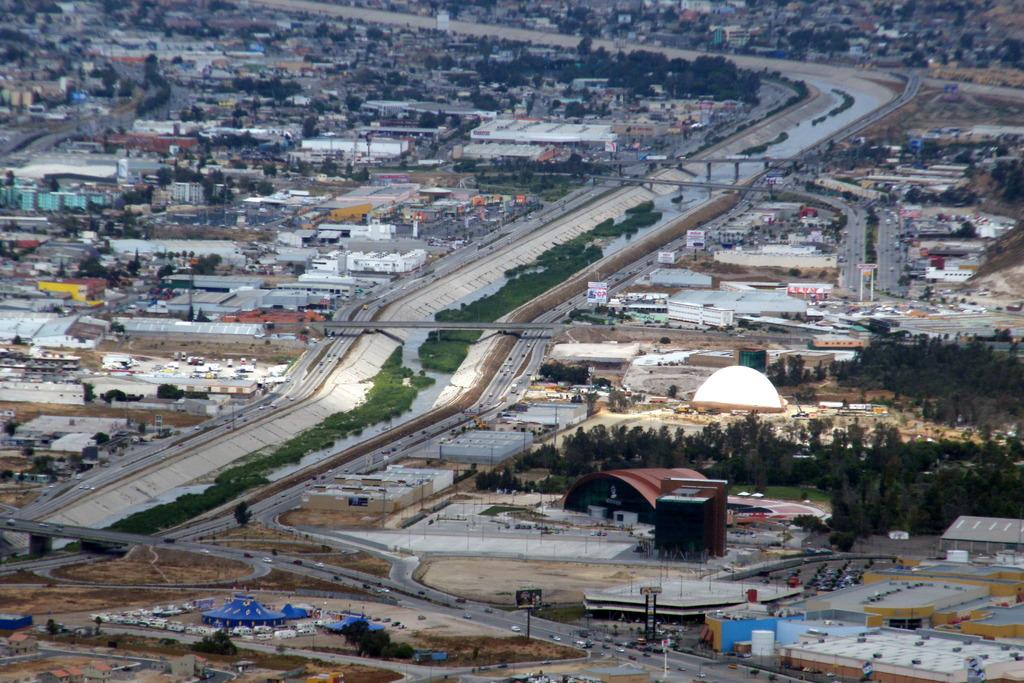What is the perspective of the image? The image shows a top view of a city. What structures can be seen in the image? There are buildings, trees, a canal, bridges, roads, and vehicles visible in the image. What type of transportation is present in the image? Vehicles can be seen in the image. What are the signs or advertisements in the image? There are hoardings and boards in the image. Where is the library located in the image? There is no library present in the image. How does the wind blow in the image? There is no indication of wind or blowing in the image. 